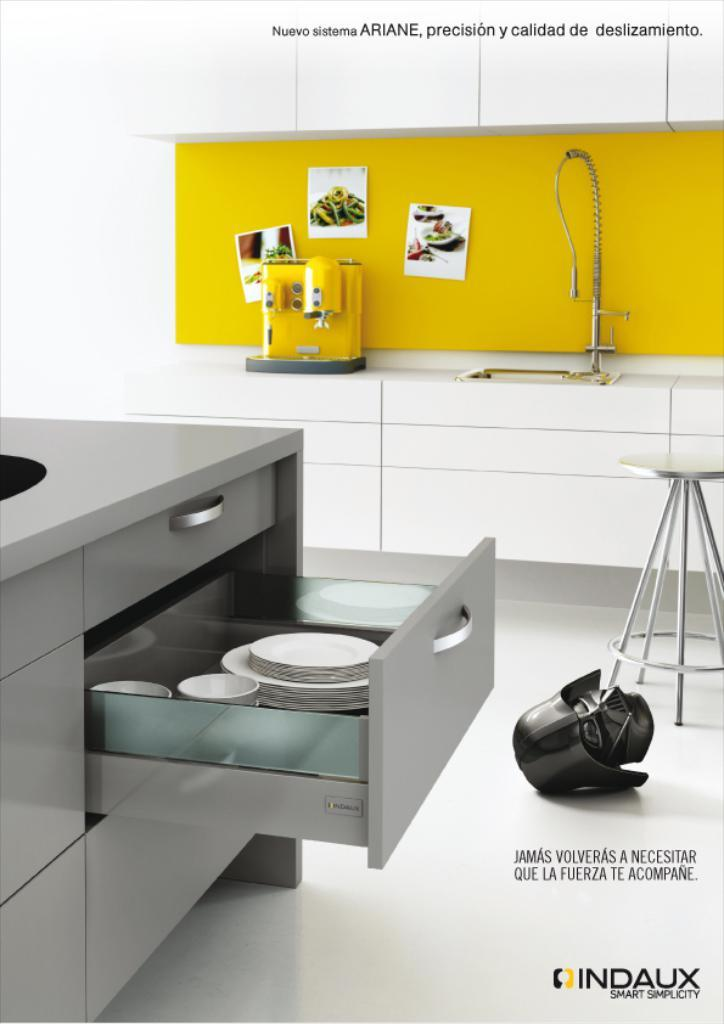Provide a one-sentence caption for the provided image. An advertisement for Indaux simplicity home furnishings shows a convenient kitchen setup. 